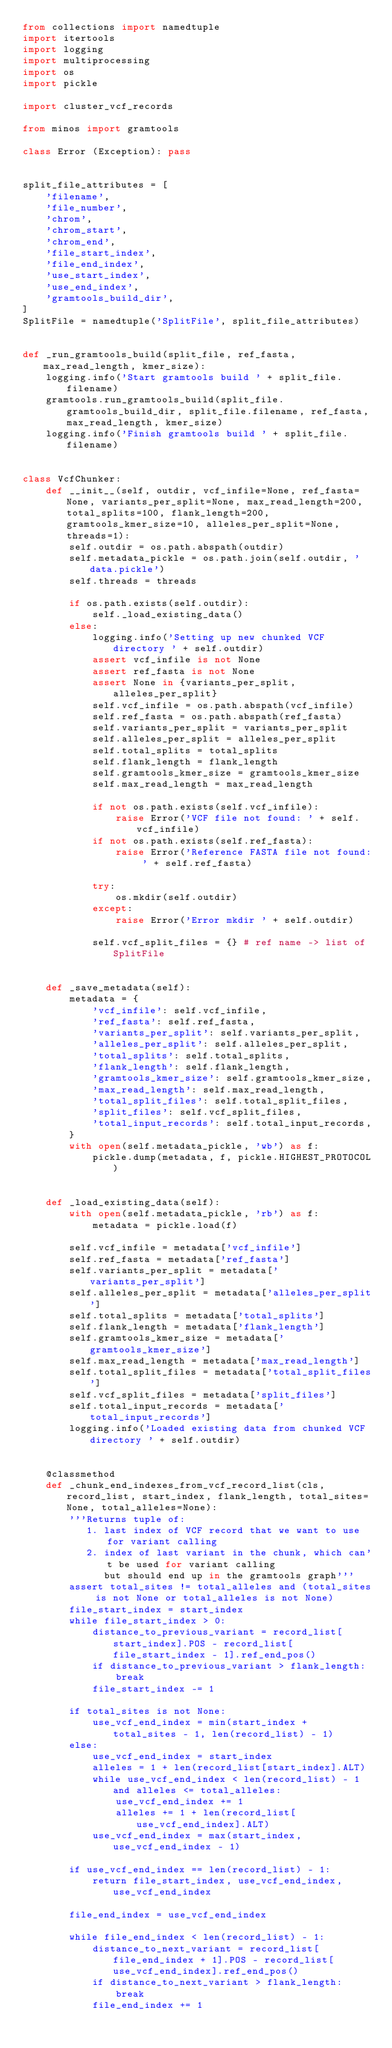<code> <loc_0><loc_0><loc_500><loc_500><_Python_>from collections import namedtuple
import itertools
import logging
import multiprocessing
import os
import pickle

import cluster_vcf_records

from minos import gramtools

class Error (Exception): pass


split_file_attributes = [
    'filename',
    'file_number',
    'chrom',
    'chrom_start',
    'chrom_end',
    'file_start_index',
    'file_end_index',
    'use_start_index',
    'use_end_index',
    'gramtools_build_dir',
]
SplitFile = namedtuple('SplitFile', split_file_attributes)


def _run_gramtools_build(split_file, ref_fasta, max_read_length, kmer_size):
    logging.info('Start gramtools build ' + split_file.filename)
    gramtools.run_gramtools_build(split_file.gramtools_build_dir, split_file.filename, ref_fasta, max_read_length, kmer_size)
    logging.info('Finish gramtools build ' + split_file.filename)


class VcfChunker:
    def __init__(self, outdir, vcf_infile=None, ref_fasta=None, variants_per_split=None, max_read_length=200, total_splits=100, flank_length=200, gramtools_kmer_size=10, alleles_per_split=None, threads=1):
        self.outdir = os.path.abspath(outdir)
        self.metadata_pickle = os.path.join(self.outdir, 'data.pickle')
        self.threads = threads

        if os.path.exists(self.outdir):
            self._load_existing_data()
        else:
            logging.info('Setting up new chunked VCF directory ' + self.outdir)
            assert vcf_infile is not None
            assert ref_fasta is not None
            assert None in {variants_per_split, alleles_per_split}
            self.vcf_infile = os.path.abspath(vcf_infile)
            self.ref_fasta = os.path.abspath(ref_fasta)
            self.variants_per_split = variants_per_split
            self.alleles_per_split = alleles_per_split
            self.total_splits = total_splits
            self.flank_length = flank_length
            self.gramtools_kmer_size = gramtools_kmer_size
            self.max_read_length = max_read_length

            if not os.path.exists(self.vcf_infile):
                raise Error('VCF file not found: ' + self.vcf_infile)
            if not os.path.exists(self.ref_fasta):
                raise Error('Reference FASTA file not found: ' + self.ref_fasta)

            try:
                os.mkdir(self.outdir)
            except:
                raise Error('Error mkdir ' + self.outdir)

            self.vcf_split_files = {} # ref name -> list of SplitFile


    def _save_metadata(self):
        metadata = {
            'vcf_infile': self.vcf_infile,
            'ref_fasta': self.ref_fasta,
            'variants_per_split': self.variants_per_split,
            'alleles_per_split': self.alleles_per_split,
            'total_splits': self.total_splits,
            'flank_length': self.flank_length,
            'gramtools_kmer_size': self.gramtools_kmer_size,
            'max_read_length': self.max_read_length,
            'total_split_files': self.total_split_files,
            'split_files': self.vcf_split_files,
            'total_input_records': self.total_input_records,
        }
        with open(self.metadata_pickle, 'wb') as f:
            pickle.dump(metadata, f, pickle.HIGHEST_PROTOCOL)


    def _load_existing_data(self):
        with open(self.metadata_pickle, 'rb') as f:
            metadata = pickle.load(f)

        self.vcf_infile = metadata['vcf_infile']
        self.ref_fasta = metadata['ref_fasta']
        self.variants_per_split = metadata['variants_per_split']
        self.alleles_per_split = metadata['alleles_per_split']
        self.total_splits = metadata['total_splits']
        self.flank_length = metadata['flank_length']
        self.gramtools_kmer_size = metadata['gramtools_kmer_size']
        self.max_read_length = metadata['max_read_length']
        self.total_split_files = metadata['total_split_files']
        self.vcf_split_files = metadata['split_files']
        self.total_input_records = metadata['total_input_records']
        logging.info('Loaded existing data from chunked VCF directory ' + self.outdir)


    @classmethod
    def _chunk_end_indexes_from_vcf_record_list(cls, record_list, start_index, flank_length, total_sites=None, total_alleles=None):
        '''Returns tuple of:
           1. last index of VCF record that we want to use for variant calling
           2. index of last variant in the chunk, which can't be used for variant calling
              but should end up in the gramtools graph'''
        assert total_sites != total_alleles and (total_sites is not None or total_alleles is not None)
        file_start_index = start_index
        while file_start_index > 0:
            distance_to_previous_variant = record_list[start_index].POS - record_list[file_start_index - 1].ref_end_pos()
            if distance_to_previous_variant > flank_length:
                break
            file_start_index -= 1

        if total_sites is not None:
            use_vcf_end_index = min(start_index + total_sites - 1, len(record_list) - 1)
        else:
            use_vcf_end_index = start_index
            alleles = 1 + len(record_list[start_index].ALT)
            while use_vcf_end_index < len(record_list) - 1 and alleles <= total_alleles:
                use_vcf_end_index += 1
                alleles += 1 + len(record_list[use_vcf_end_index].ALT)
            use_vcf_end_index = max(start_index, use_vcf_end_index - 1)

        if use_vcf_end_index == len(record_list) - 1:
            return file_start_index, use_vcf_end_index, use_vcf_end_index

        file_end_index = use_vcf_end_index

        while file_end_index < len(record_list) - 1:
            distance_to_next_variant = record_list[file_end_index + 1].POS - record_list[use_vcf_end_index].ref_end_pos()
            if distance_to_next_variant > flank_length:
                break
            file_end_index += 1
</code> 